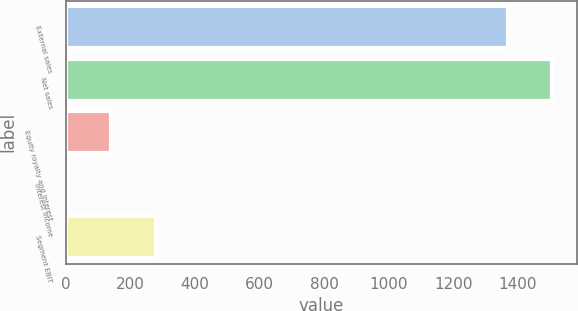<chart> <loc_0><loc_0><loc_500><loc_500><bar_chart><fcel>External sales<fcel>Net sales<fcel>Equity royalty and interest<fcel>Interest income<fcel>Segment EBIT<nl><fcel>1369<fcel>1507.3<fcel>140.3<fcel>2<fcel>278.6<nl></chart> 